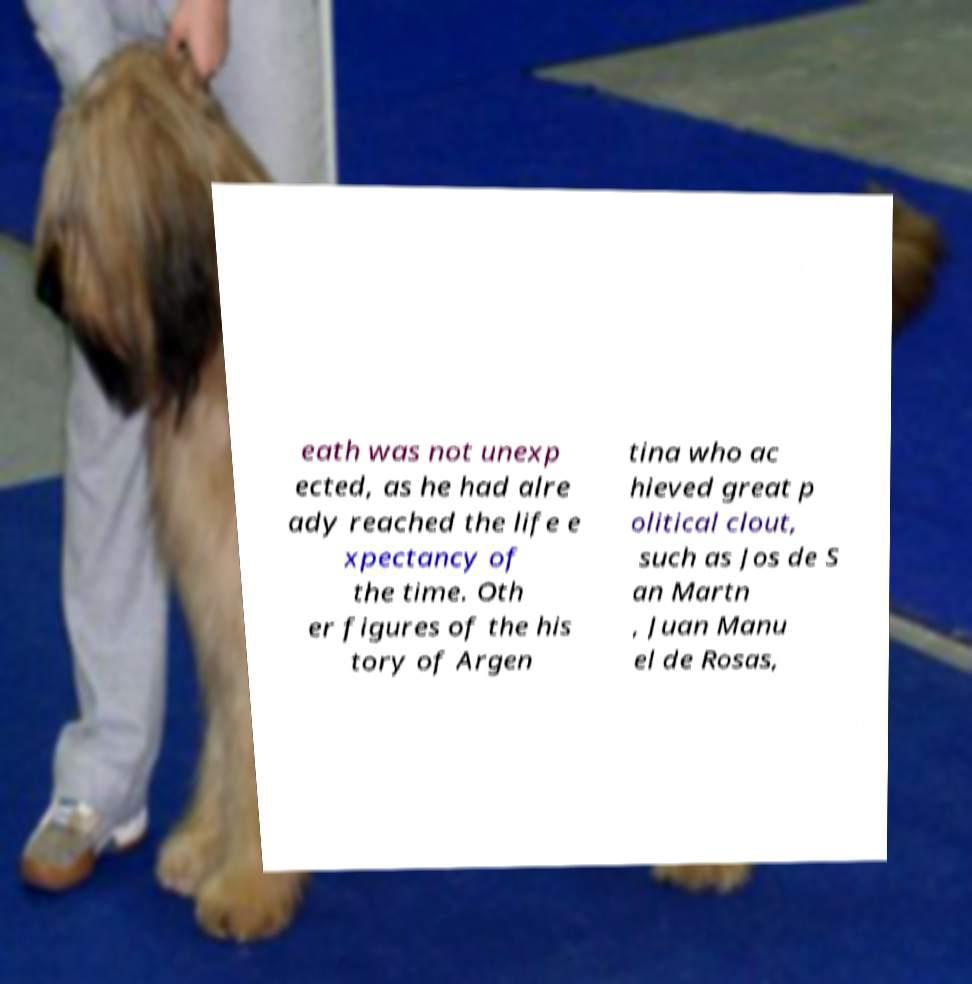Could you assist in decoding the text presented in this image and type it out clearly? eath was not unexp ected, as he had alre ady reached the life e xpectancy of the time. Oth er figures of the his tory of Argen tina who ac hieved great p olitical clout, such as Jos de S an Martn , Juan Manu el de Rosas, 